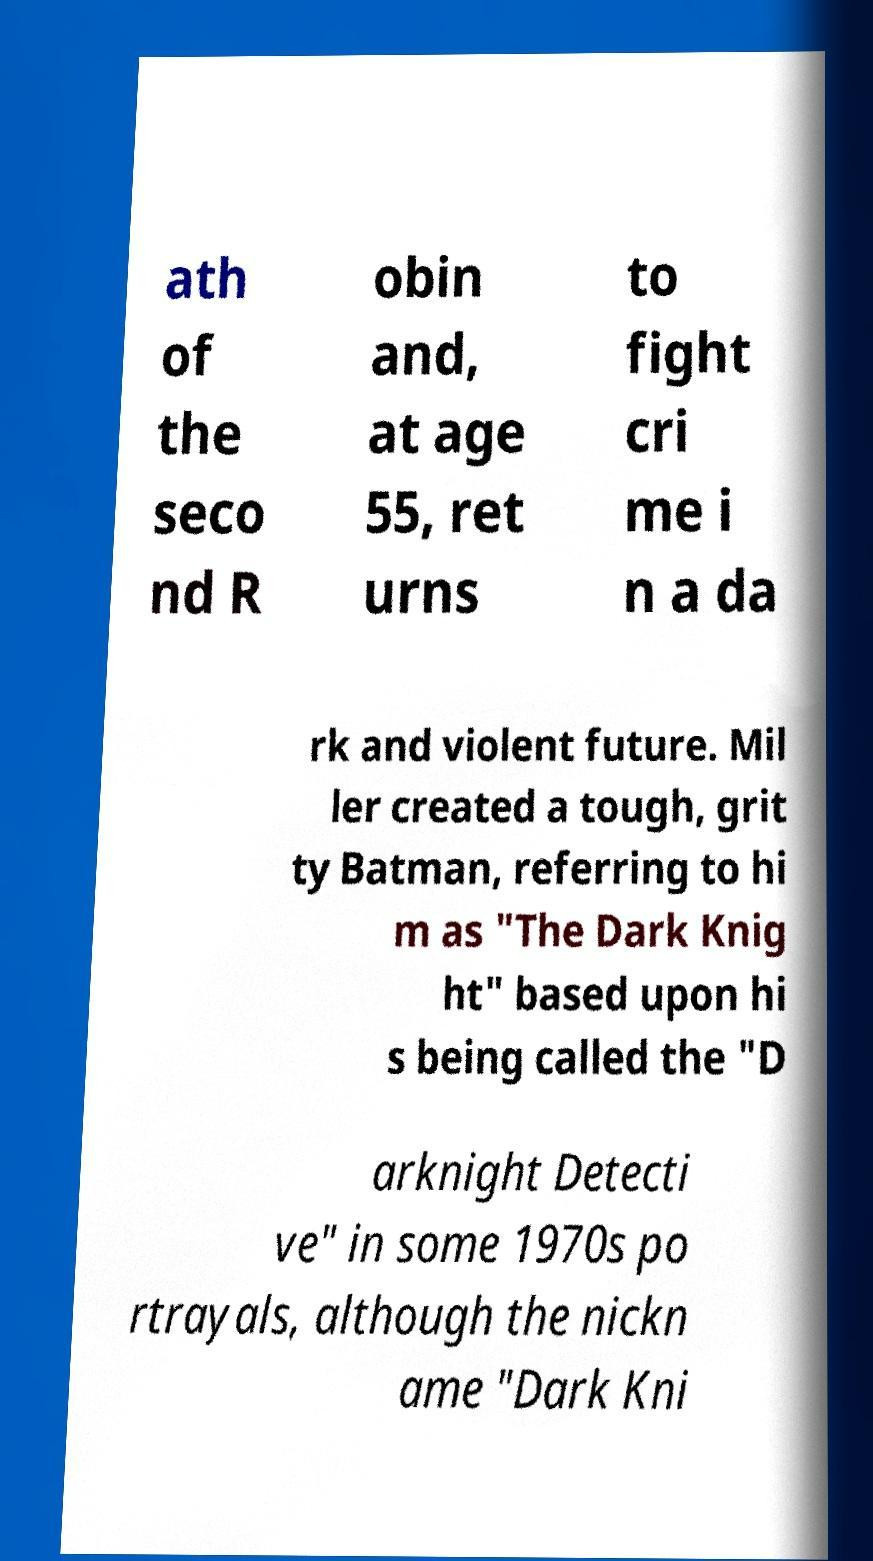What messages or text are displayed in this image? I need them in a readable, typed format. ath of the seco nd R obin and, at age 55, ret urns to fight cri me i n a da rk and violent future. Mil ler created a tough, grit ty Batman, referring to hi m as "The Dark Knig ht" based upon hi s being called the "D arknight Detecti ve" in some 1970s po rtrayals, although the nickn ame "Dark Kni 